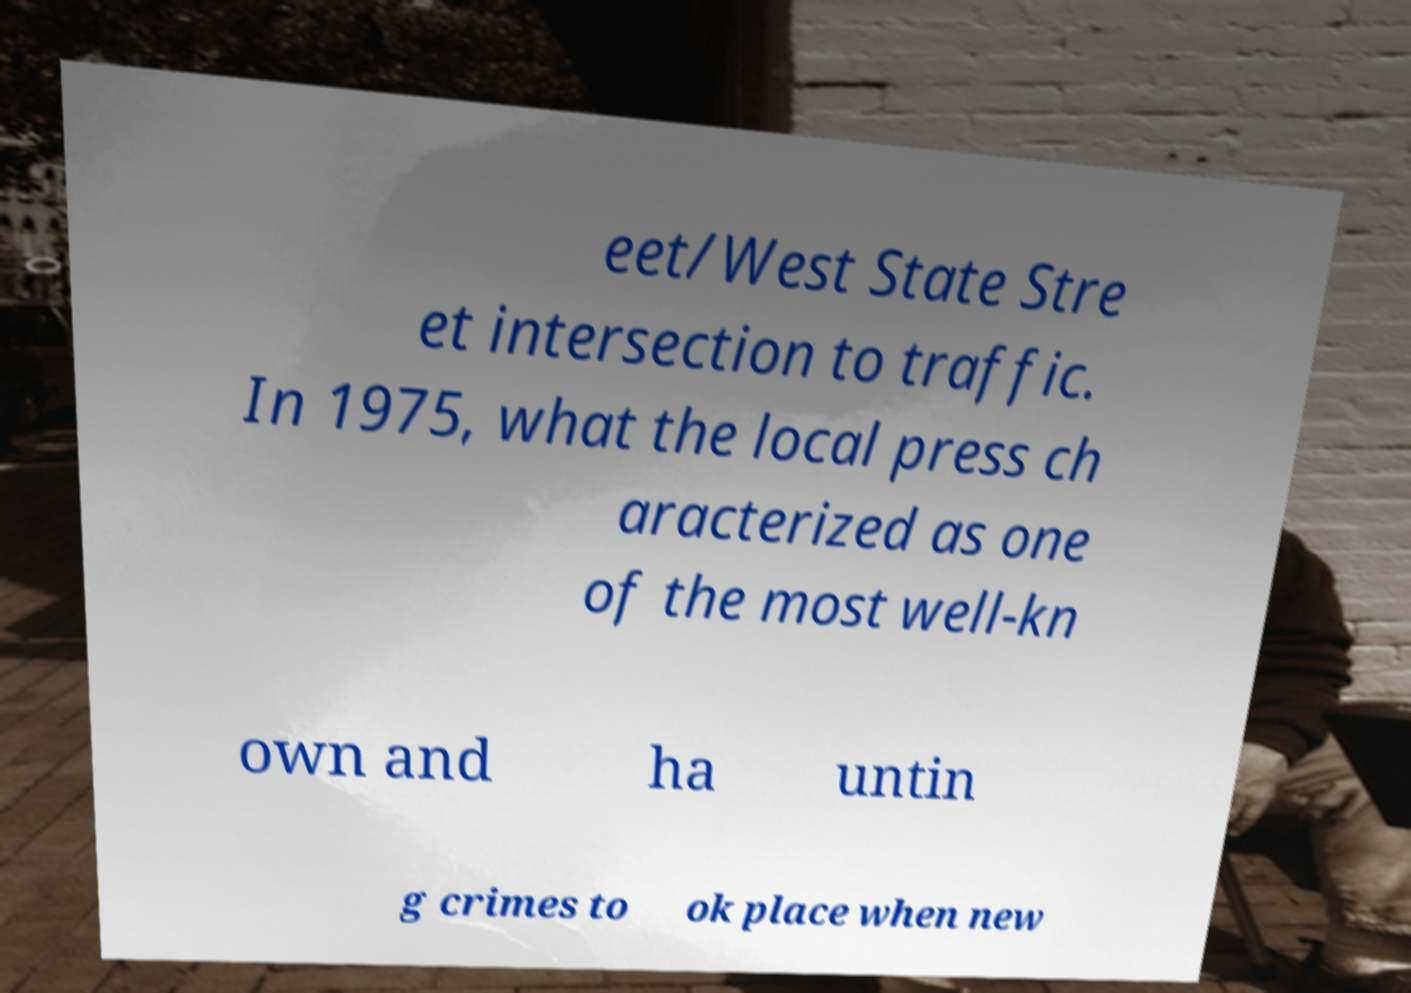What messages or text are displayed in this image? I need them in a readable, typed format. eet/West State Stre et intersection to traffic. In 1975, what the local press ch aracterized as one of the most well-kn own and ha untin g crimes to ok place when new 